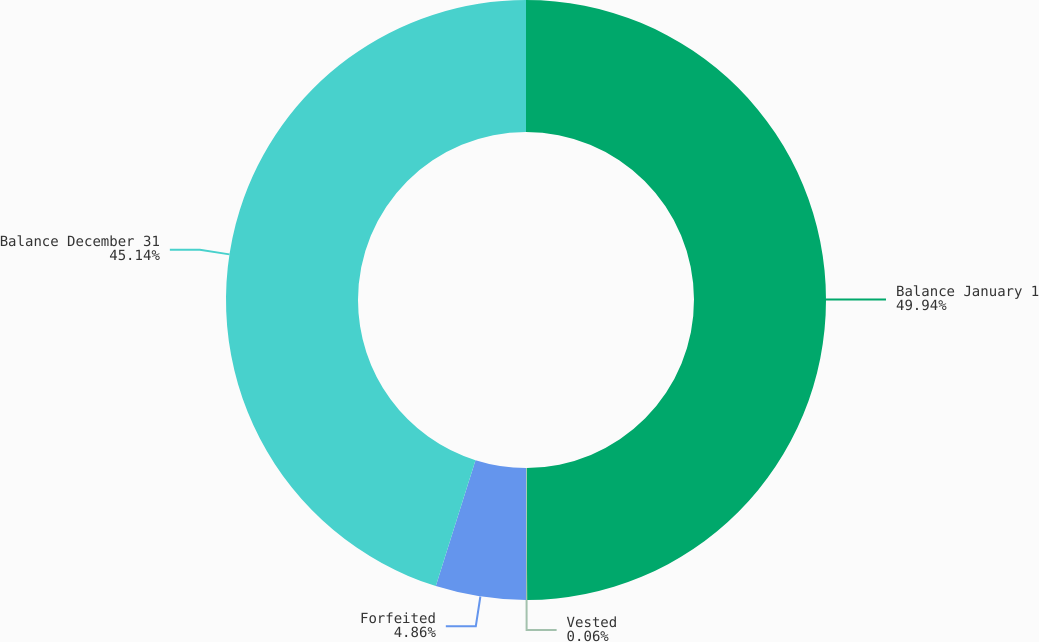Convert chart to OTSL. <chart><loc_0><loc_0><loc_500><loc_500><pie_chart><fcel>Balance January 1<fcel>Vested<fcel>Forfeited<fcel>Balance December 31<nl><fcel>49.94%<fcel>0.06%<fcel>4.86%<fcel>45.14%<nl></chart> 